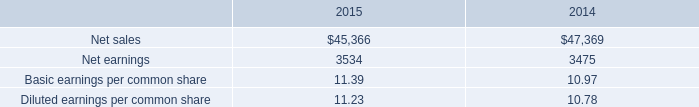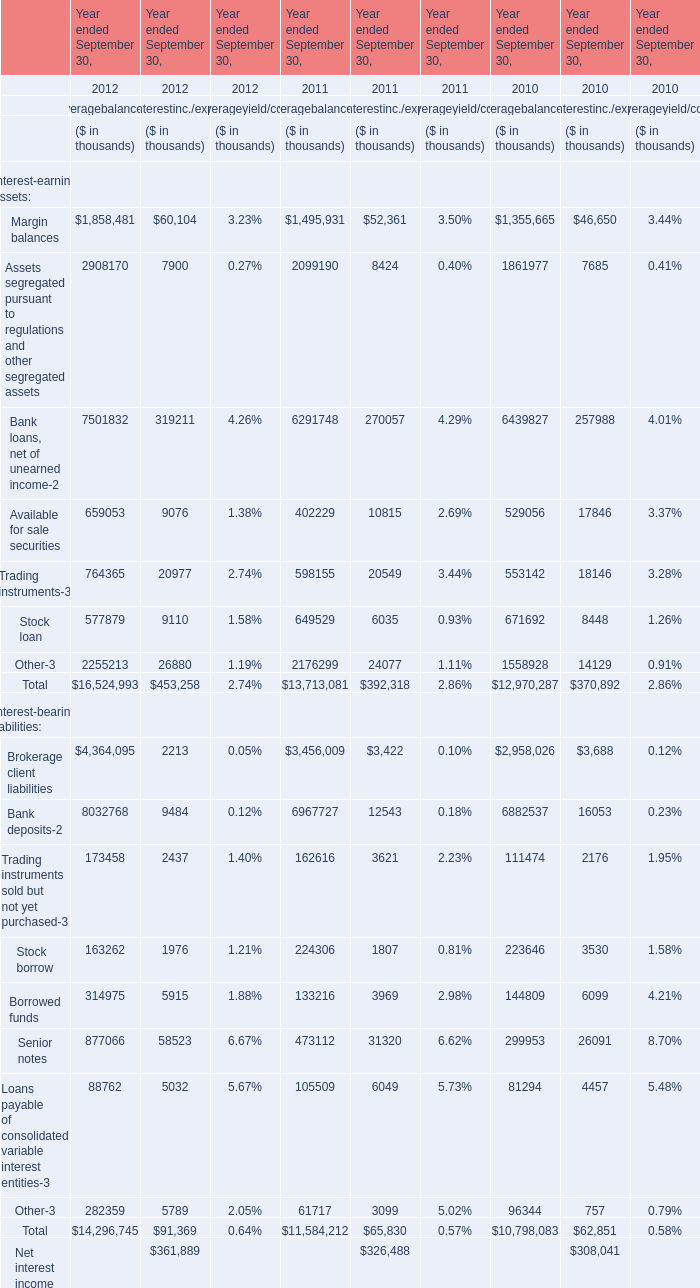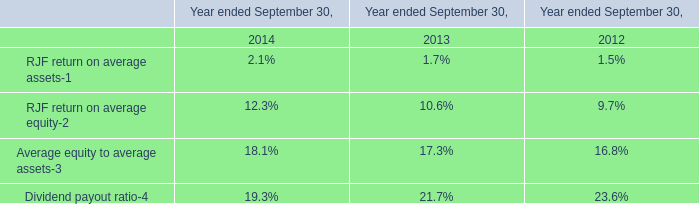What is the sum of the Assets segregated pursuant to regulations and other segregated assets in the years where Margin balancesis positive? (in thousand) 
Computations: (((2908170 + 7900) + 2099190) + 8424)
Answer: 5023684.0. 